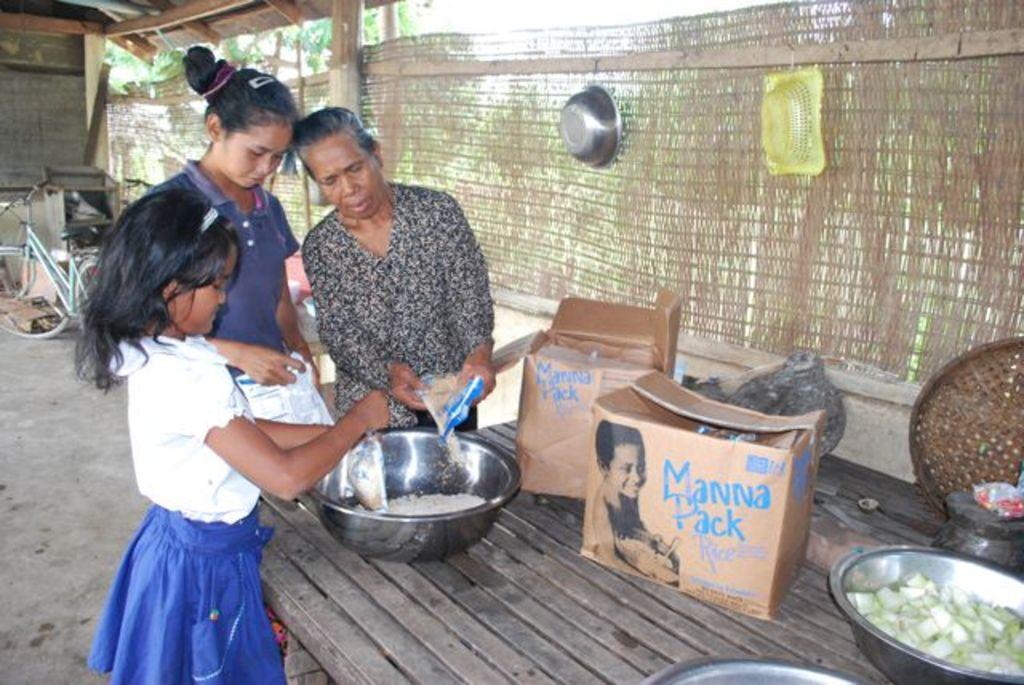How would you summarize this image in a sentence or two? In the image we can see there are people standing near the table and there is a bowl of flour kept on the table. The people are holding flour packets in their hand and there are baskets kept on the wall. Behind there is a bicycle kept on the ground. 